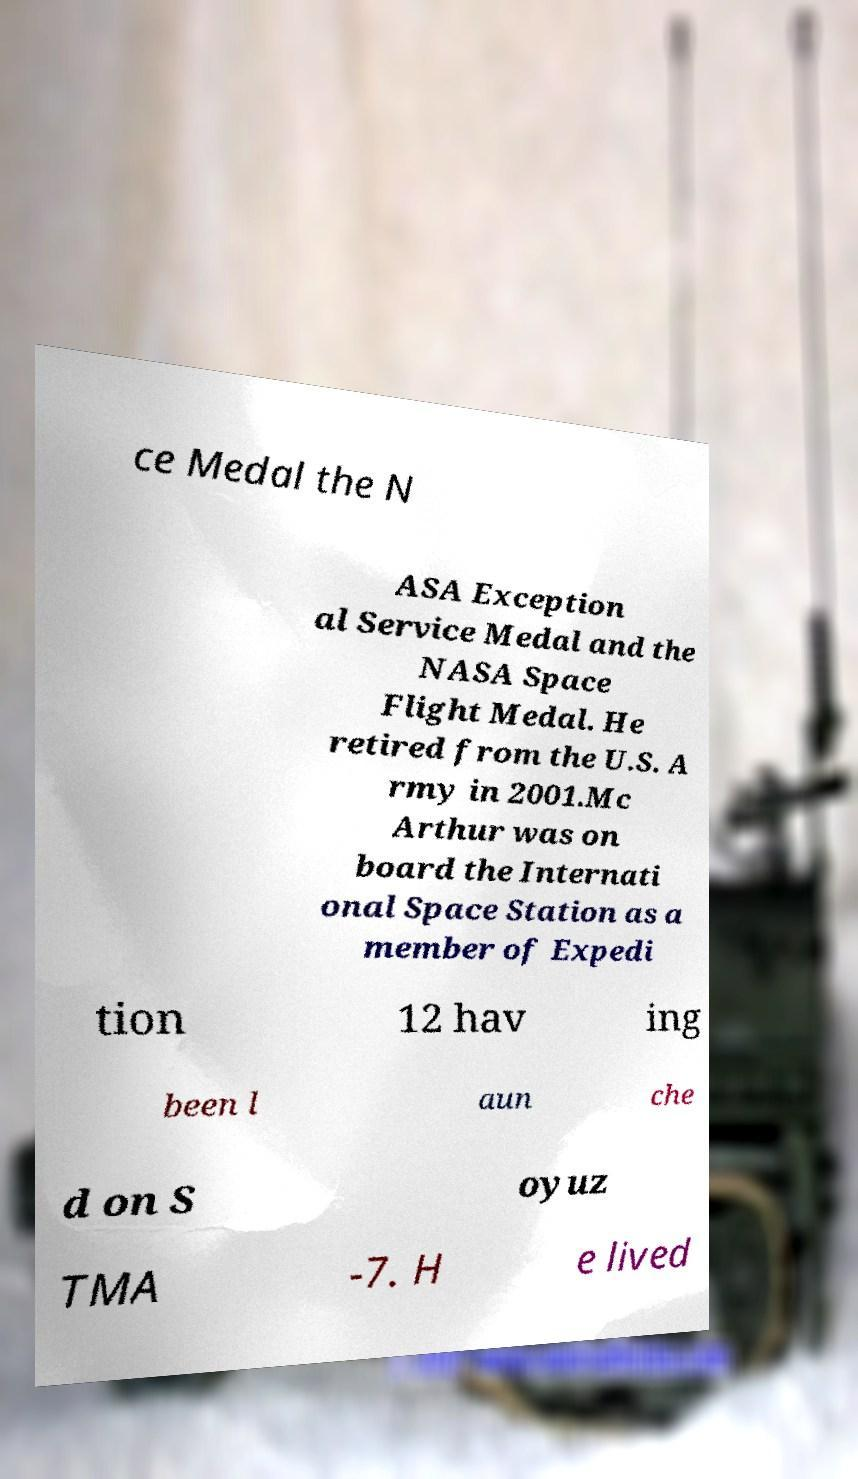I need the written content from this picture converted into text. Can you do that? ce Medal the N ASA Exception al Service Medal and the NASA Space Flight Medal. He retired from the U.S. A rmy in 2001.Mc Arthur was on board the Internati onal Space Station as a member of Expedi tion 12 hav ing been l aun che d on S oyuz TMA -7. H e lived 